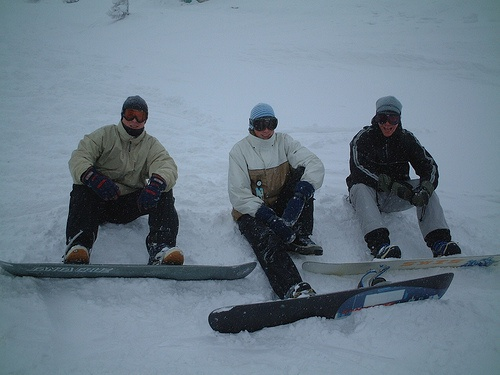Describe the objects in this image and their specific colors. I can see people in gray, black, maroon, and darkgray tones, people in gray and black tones, people in gray, black, and darkblue tones, snowboard in gray, black, navy, and blue tones, and snowboard in gray, blue, black, and darkblue tones in this image. 